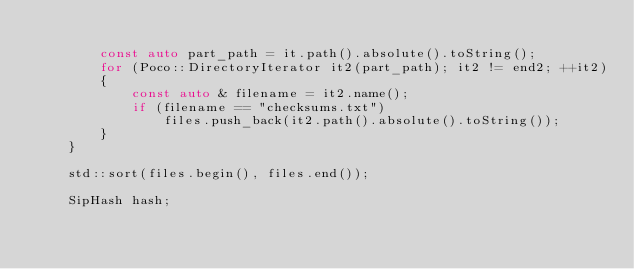<code> <loc_0><loc_0><loc_500><loc_500><_C++_>
        const auto part_path = it.path().absolute().toString();
        for (Poco::DirectoryIterator it2(part_path); it2 != end2; ++it2)
        {
            const auto & filename = it2.name();
            if (filename == "checksums.txt")
                files.push_back(it2.path().absolute().toString());
        }
    }

    std::sort(files.begin(), files.end());

    SipHash hash;
</code> 